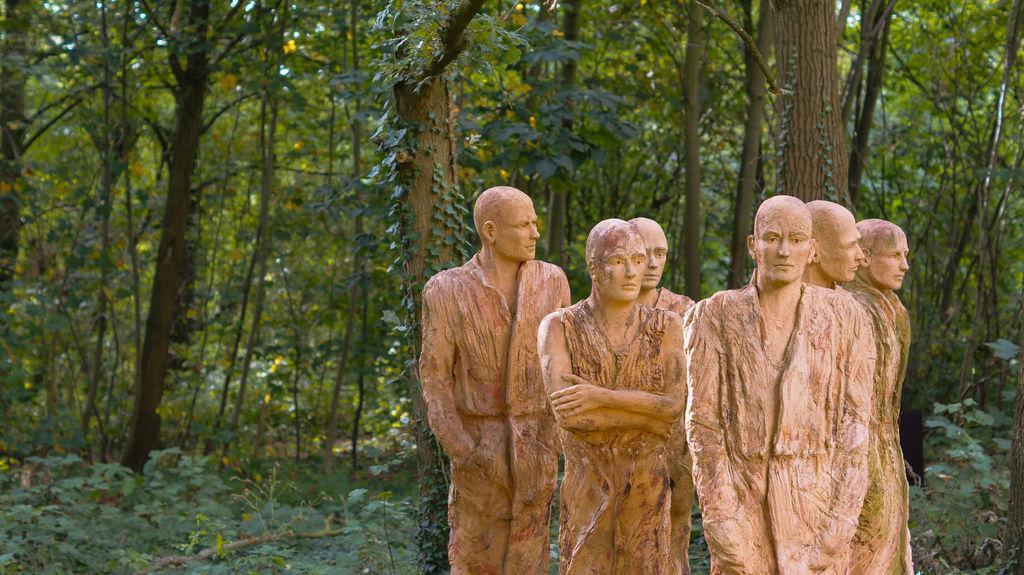In one or two sentences, can you explain what this image depicts? In the center of the image there are depictions of a person. In the background of the image there are trees. 